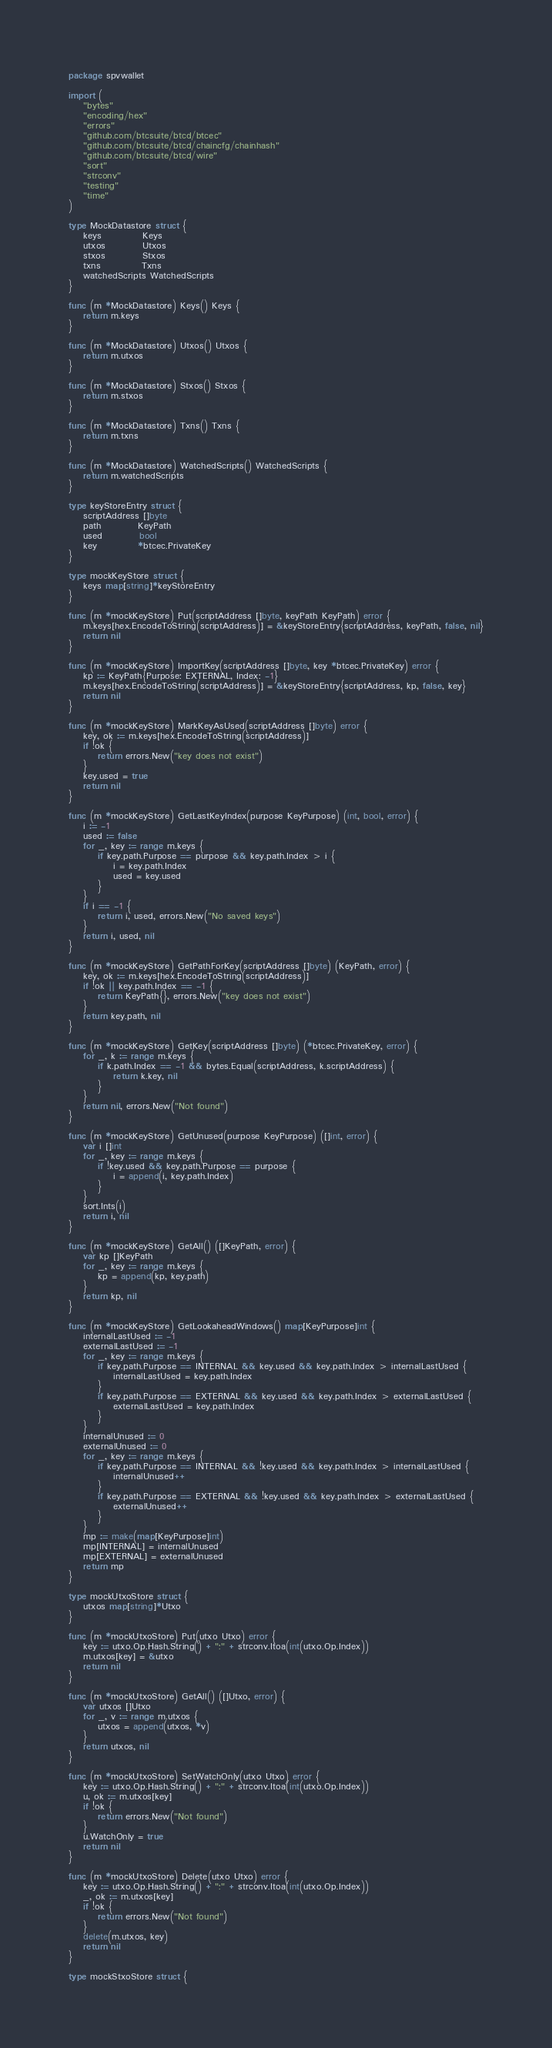Convert code to text. <code><loc_0><loc_0><loc_500><loc_500><_Go_>package spvwallet

import (
	"bytes"
	"encoding/hex"
	"errors"
	"github.com/btcsuite/btcd/btcec"
	"github.com/btcsuite/btcd/chaincfg/chainhash"
	"github.com/btcsuite/btcd/wire"
	"sort"
	"strconv"
	"testing"
	"time"
)

type MockDatastore struct {
	keys           Keys
	utxos          Utxos
	stxos          Stxos
	txns           Txns
	watchedScripts WatchedScripts
}

func (m *MockDatastore) Keys() Keys {
	return m.keys
}

func (m *MockDatastore) Utxos() Utxos {
	return m.utxos
}

func (m *MockDatastore) Stxos() Stxos {
	return m.stxos
}

func (m *MockDatastore) Txns() Txns {
	return m.txns
}

func (m *MockDatastore) WatchedScripts() WatchedScripts {
	return m.watchedScripts
}

type keyStoreEntry struct {
	scriptAddress []byte
	path          KeyPath
	used          bool
	key           *btcec.PrivateKey
}

type mockKeyStore struct {
	keys map[string]*keyStoreEntry
}

func (m *mockKeyStore) Put(scriptAddress []byte, keyPath KeyPath) error {
	m.keys[hex.EncodeToString(scriptAddress)] = &keyStoreEntry{scriptAddress, keyPath, false, nil}
	return nil
}

func (m *mockKeyStore) ImportKey(scriptAddress []byte, key *btcec.PrivateKey) error {
	kp := KeyPath{Purpose: EXTERNAL, Index: -1}
	m.keys[hex.EncodeToString(scriptAddress)] = &keyStoreEntry{scriptAddress, kp, false, key}
	return nil
}

func (m *mockKeyStore) MarkKeyAsUsed(scriptAddress []byte) error {
	key, ok := m.keys[hex.EncodeToString(scriptAddress)]
	if !ok {
		return errors.New("key does not exist")
	}
	key.used = true
	return nil
}

func (m *mockKeyStore) GetLastKeyIndex(purpose KeyPurpose) (int, bool, error) {
	i := -1
	used := false
	for _, key := range m.keys {
		if key.path.Purpose == purpose && key.path.Index > i {
			i = key.path.Index
			used = key.used
		}
	}
	if i == -1 {
		return i, used, errors.New("No saved keys")
	}
	return i, used, nil
}

func (m *mockKeyStore) GetPathForKey(scriptAddress []byte) (KeyPath, error) {
	key, ok := m.keys[hex.EncodeToString(scriptAddress)]
	if !ok || key.path.Index == -1 {
		return KeyPath{}, errors.New("key does not exist")
	}
	return key.path, nil
}

func (m *mockKeyStore) GetKey(scriptAddress []byte) (*btcec.PrivateKey, error) {
	for _, k := range m.keys {
		if k.path.Index == -1 && bytes.Equal(scriptAddress, k.scriptAddress) {
			return k.key, nil
		}
	}
	return nil, errors.New("Not found")
}

func (m *mockKeyStore) GetUnused(purpose KeyPurpose) ([]int, error) {
	var i []int
	for _, key := range m.keys {
		if !key.used && key.path.Purpose == purpose {
			i = append(i, key.path.Index)
		}
	}
	sort.Ints(i)
	return i, nil
}

func (m *mockKeyStore) GetAll() ([]KeyPath, error) {
	var kp []KeyPath
	for _, key := range m.keys {
		kp = append(kp, key.path)
	}
	return kp, nil
}

func (m *mockKeyStore) GetLookaheadWindows() map[KeyPurpose]int {
	internalLastUsed := -1
	externalLastUsed := -1
	for _, key := range m.keys {
		if key.path.Purpose == INTERNAL && key.used && key.path.Index > internalLastUsed {
			internalLastUsed = key.path.Index
		}
		if key.path.Purpose == EXTERNAL && key.used && key.path.Index > externalLastUsed {
			externalLastUsed = key.path.Index
		}
	}
	internalUnused := 0
	externalUnused := 0
	for _, key := range m.keys {
		if key.path.Purpose == INTERNAL && !key.used && key.path.Index > internalLastUsed {
			internalUnused++
		}
		if key.path.Purpose == EXTERNAL && !key.used && key.path.Index > externalLastUsed {
			externalUnused++
		}
	}
	mp := make(map[KeyPurpose]int)
	mp[INTERNAL] = internalUnused
	mp[EXTERNAL] = externalUnused
	return mp
}

type mockUtxoStore struct {
	utxos map[string]*Utxo
}

func (m *mockUtxoStore) Put(utxo Utxo) error {
	key := utxo.Op.Hash.String() + ":" + strconv.Itoa(int(utxo.Op.Index))
	m.utxos[key] = &utxo
	return nil
}

func (m *mockUtxoStore) GetAll() ([]Utxo, error) {
	var utxos []Utxo
	for _, v := range m.utxos {
		utxos = append(utxos, *v)
	}
	return utxos, nil
}

func (m *mockUtxoStore) SetWatchOnly(utxo Utxo) error {
	key := utxo.Op.Hash.String() + ":" + strconv.Itoa(int(utxo.Op.Index))
	u, ok := m.utxos[key]
	if !ok {
		return errors.New("Not found")
	}
	u.WatchOnly = true
	return nil
}

func (m *mockUtxoStore) Delete(utxo Utxo) error {
	key := utxo.Op.Hash.String() + ":" + strconv.Itoa(int(utxo.Op.Index))
	_, ok := m.utxos[key]
	if !ok {
		return errors.New("Not found")
	}
	delete(m.utxos, key)
	return nil
}

type mockStxoStore struct {</code> 